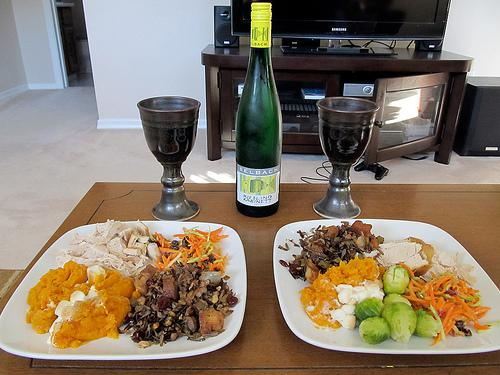Question: why is the photo illuminated?
Choices:
A. Lightbulbs.
B. Nightvision.
C. Sunlight.
D. The flash.
Answer with the letter. Answer: C 